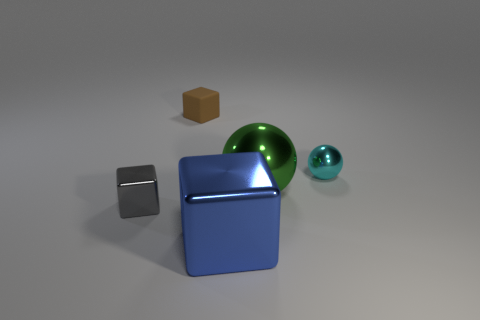Subtract all metal cubes. How many cubes are left? 1 Subtract all balls. How many objects are left? 3 Subtract 3 cubes. How many cubes are left? 0 Subtract all red balls. Subtract all brown blocks. How many balls are left? 2 Subtract all yellow cubes. How many cyan balls are left? 1 Subtract all small metallic blocks. Subtract all green metal cylinders. How many objects are left? 4 Add 3 gray metallic things. How many gray metallic things are left? 4 Add 2 green matte things. How many green matte things exist? 2 Add 5 large gray matte objects. How many objects exist? 10 Subtract all green spheres. How many spheres are left? 1 